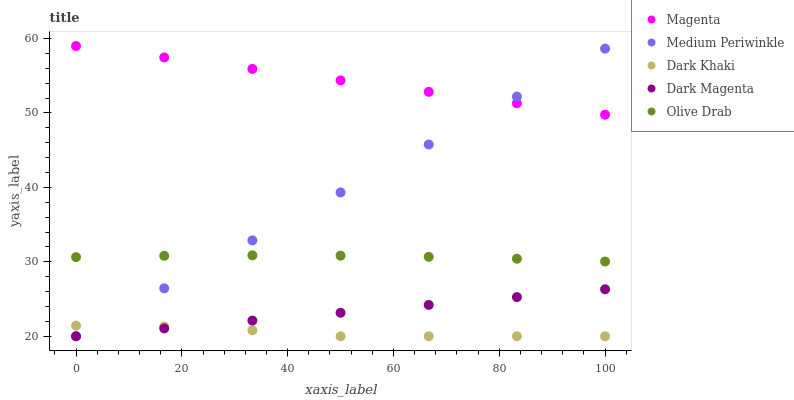Does Dark Khaki have the minimum area under the curve?
Answer yes or no. Yes. Does Magenta have the maximum area under the curve?
Answer yes or no. Yes. Does Medium Periwinkle have the minimum area under the curve?
Answer yes or no. No. Does Medium Periwinkle have the maximum area under the curve?
Answer yes or no. No. Is Dark Magenta the smoothest?
Answer yes or no. Yes. Is Dark Khaki the roughest?
Answer yes or no. Yes. Is Magenta the smoothest?
Answer yes or no. No. Is Magenta the roughest?
Answer yes or no. No. Does Dark Khaki have the lowest value?
Answer yes or no. Yes. Does Magenta have the lowest value?
Answer yes or no. No. Does Magenta have the highest value?
Answer yes or no. Yes. Does Medium Periwinkle have the highest value?
Answer yes or no. No. Is Dark Khaki less than Magenta?
Answer yes or no. Yes. Is Olive Drab greater than Dark Magenta?
Answer yes or no. Yes. Does Dark Khaki intersect Medium Periwinkle?
Answer yes or no. Yes. Is Dark Khaki less than Medium Periwinkle?
Answer yes or no. No. Is Dark Khaki greater than Medium Periwinkle?
Answer yes or no. No. Does Dark Khaki intersect Magenta?
Answer yes or no. No. 